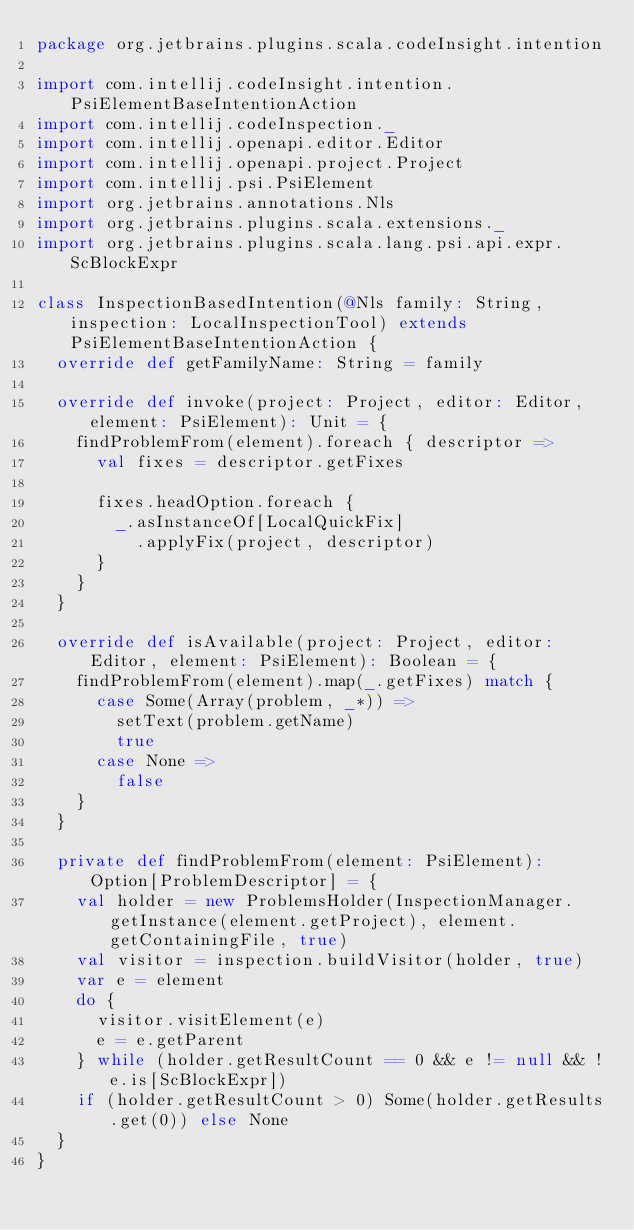Convert code to text. <code><loc_0><loc_0><loc_500><loc_500><_Scala_>package org.jetbrains.plugins.scala.codeInsight.intention

import com.intellij.codeInsight.intention.PsiElementBaseIntentionAction
import com.intellij.codeInspection._
import com.intellij.openapi.editor.Editor
import com.intellij.openapi.project.Project
import com.intellij.psi.PsiElement
import org.jetbrains.annotations.Nls
import org.jetbrains.plugins.scala.extensions._
import org.jetbrains.plugins.scala.lang.psi.api.expr.ScBlockExpr

class InspectionBasedIntention(@Nls family: String, inspection: LocalInspectionTool) extends PsiElementBaseIntentionAction {
  override def getFamilyName: String = family

  override def invoke(project: Project, editor: Editor, element: PsiElement): Unit = {
    findProblemFrom(element).foreach { descriptor =>
      val fixes = descriptor.getFixes

      fixes.headOption.foreach {
        _.asInstanceOf[LocalQuickFix]
          .applyFix(project, descriptor)
      }
    }
  }

  override def isAvailable(project: Project, editor: Editor, element: PsiElement): Boolean = {
    findProblemFrom(element).map(_.getFixes) match {
      case Some(Array(problem, _*)) =>
        setText(problem.getName)
        true
      case None =>
        false
    }
  }

  private def findProblemFrom(element: PsiElement): Option[ProblemDescriptor] = {
    val holder = new ProblemsHolder(InspectionManager.getInstance(element.getProject), element.getContainingFile, true)
    val visitor = inspection.buildVisitor(holder, true)
    var e = element
    do {
      visitor.visitElement(e)
      e = e.getParent
    } while (holder.getResultCount == 0 && e != null && !e.is[ScBlockExpr])
    if (holder.getResultCount > 0) Some(holder.getResults.get(0)) else None
  }
}
</code> 